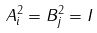Convert formula to latex. <formula><loc_0><loc_0><loc_500><loc_500>A _ { i } ^ { 2 } = B _ { j } ^ { 2 } = I</formula> 